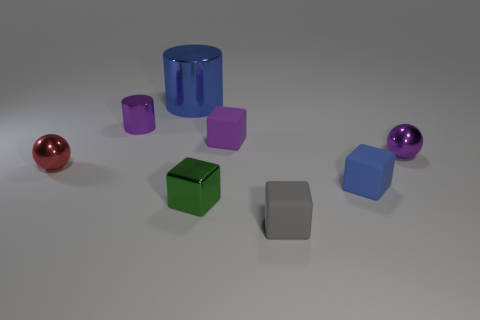Is there any other thing that has the same size as the blue metal cylinder?
Provide a short and direct response. No. The tiny block that is behind the ball that is on the right side of the red ball is made of what material?
Your answer should be compact. Rubber. Are there any tiny rubber cubes in front of the green cube?
Offer a terse response. Yes. Is the number of green blocks to the left of the large cylinder greater than the number of tiny gray metal cubes?
Offer a terse response. No. Is there a cylinder that has the same color as the small shiny block?
Give a very brief answer. No. There is a cylinder that is the same size as the gray thing; what color is it?
Make the answer very short. Purple. There is a tiny purple metal thing that is behind the purple rubber cube; are there any tiny blocks that are behind it?
Your answer should be very brief. No. What is the material of the small purple object that is to the left of the blue metallic thing?
Your answer should be very brief. Metal. Is the material of the object that is left of the tiny cylinder the same as the thing behind the purple shiny cylinder?
Offer a terse response. Yes. Are there an equal number of gray matte cubes behind the red ball and tiny red objects in front of the blue matte object?
Provide a short and direct response. Yes. 